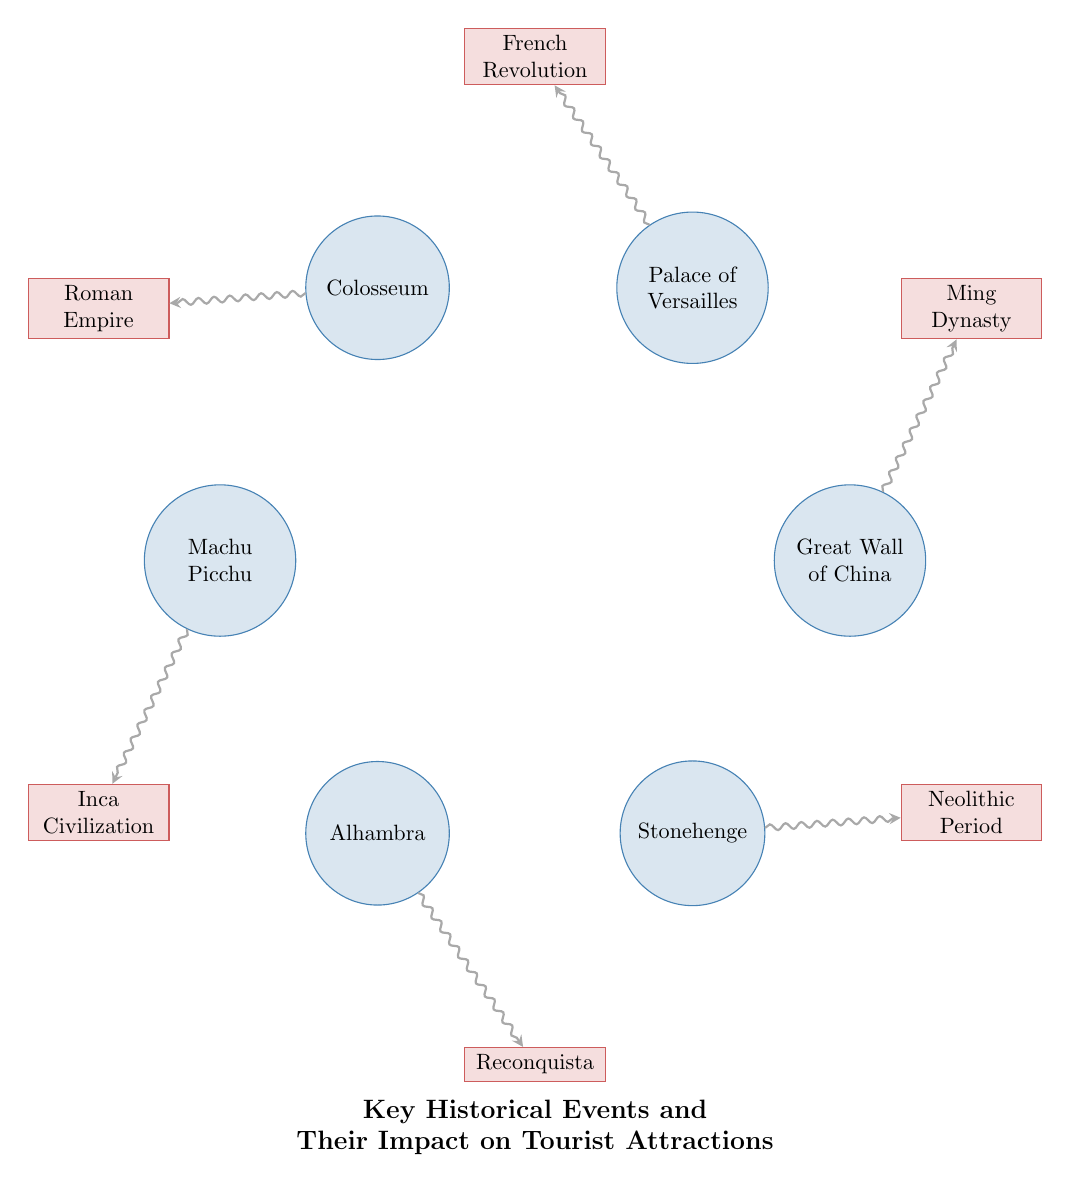What tourist attraction is linked to the Ming Dynasty? The diagram shows a link from the Great Wall of China to the Ming Dynasty. Therefore, the answer is the Great Wall of China.
Answer: Great Wall of China Which historical event is associated with the Palace of Versailles? The diagram indicates a connection from the Palace of Versailles to the French Revolution. Hence, the answer is the French Revolution.
Answer: French Revolution How many nodes are present in the diagram? The diagram includes a total of six tourist attractions and six historical events, making it a total of twelve nodes. Thus, the answer is twelve.
Answer: twelve Which tourist attraction connects to the Roman Empire? Referring to the diagram, the Colosseum is the tourist attraction linked to the Roman Empire.
Answer: Colosseum What is the value for the link between Alhambra and Reconquista? All links show a 'value' of 2. Thus, the value for the link between Alhambra and Reconquista is 2.
Answer: 2 What is the relationship between Machu Picchu and Inca Civilization? The diagram shows a direct link from Machu Picchu to Inca Civilization, thus indicating that Machu Picchu is associated with the Inca Civilization.
Answer: Inca Civilization Which historical events impact more than one tourist attraction? Examining the diagram, all historical events (Ming Dynasty, French Revolution, Roman Empire, Inca Civilization, Reconquista, Neolithic Period) only connect to one tourist attraction each. Therefore, no historical events impact more than one attraction.
Answer: None Which tourist attraction is linked to the Neolithic Period? The only tourist attraction connected to the Neolithic Period is Stonehenge according to the diagram's representation.
Answer: Stonehenge Identify the tourist attraction that has a direct link to an event related to a period of civilization. Analyzing the diagram, the connection of Machu Picchu with Inca Civilization represents a direct link to a historical period related to civilization.
Answer: Inca Civilization 